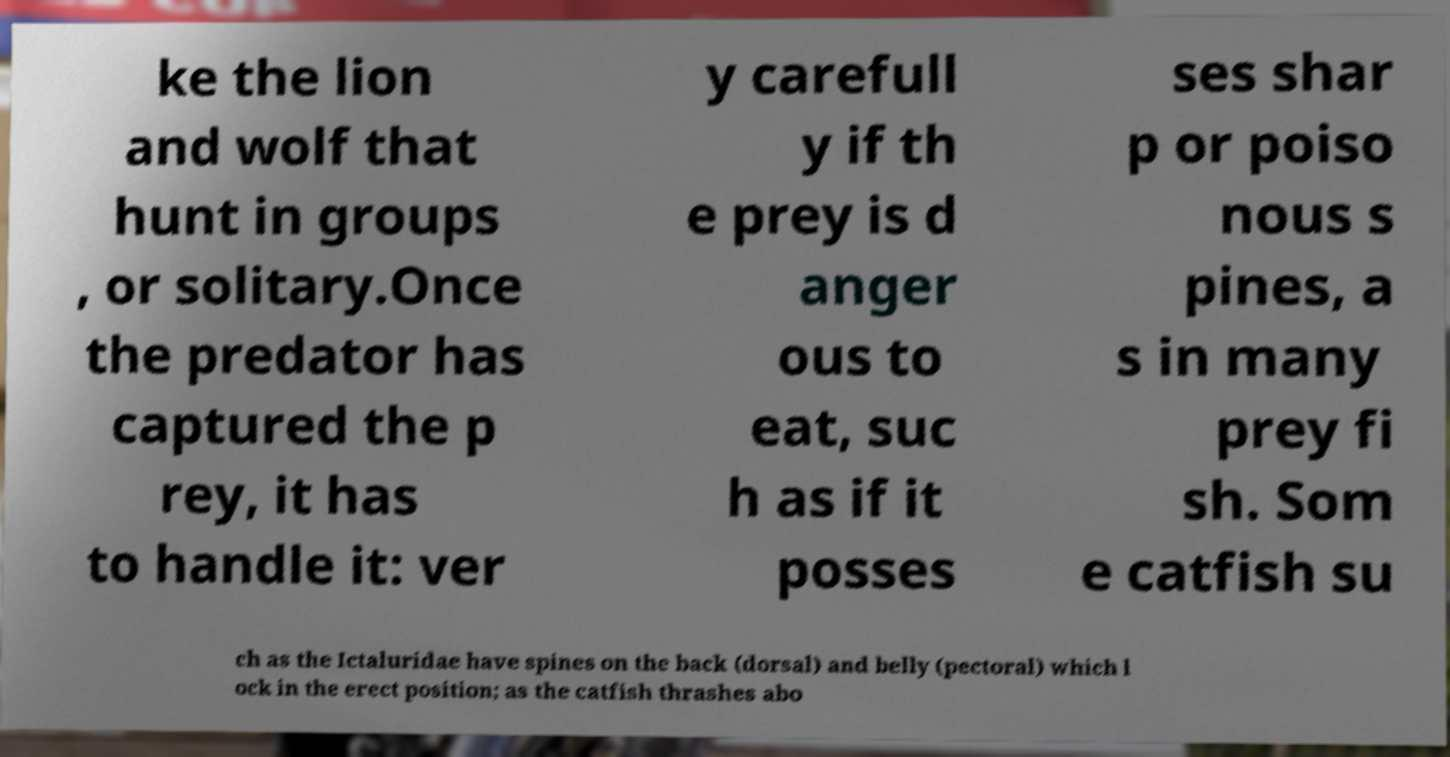What messages or text are displayed in this image? I need them in a readable, typed format. ke the lion and wolf that hunt in groups , or solitary.Once the predator has captured the p rey, it has to handle it: ver y carefull y if th e prey is d anger ous to eat, suc h as if it posses ses shar p or poiso nous s pines, a s in many prey fi sh. Som e catfish su ch as the Ictaluridae have spines on the back (dorsal) and belly (pectoral) which l ock in the erect position; as the catfish thrashes abo 